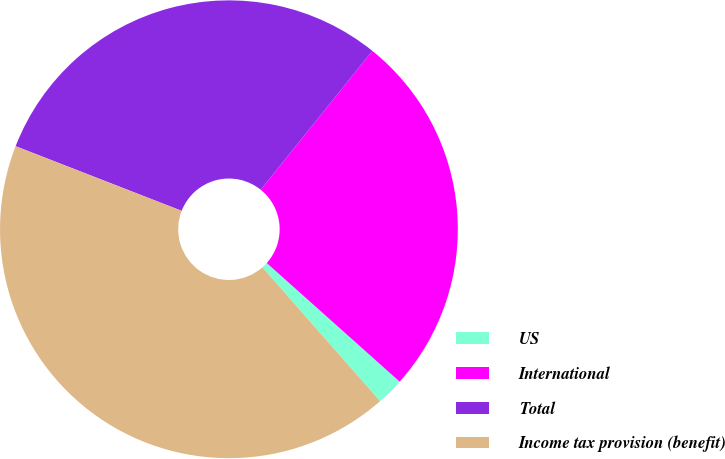<chart> <loc_0><loc_0><loc_500><loc_500><pie_chart><fcel>US<fcel>International<fcel>Total<fcel>Income tax provision (benefit)<nl><fcel>1.92%<fcel>25.82%<fcel>29.87%<fcel>42.39%<nl></chart> 